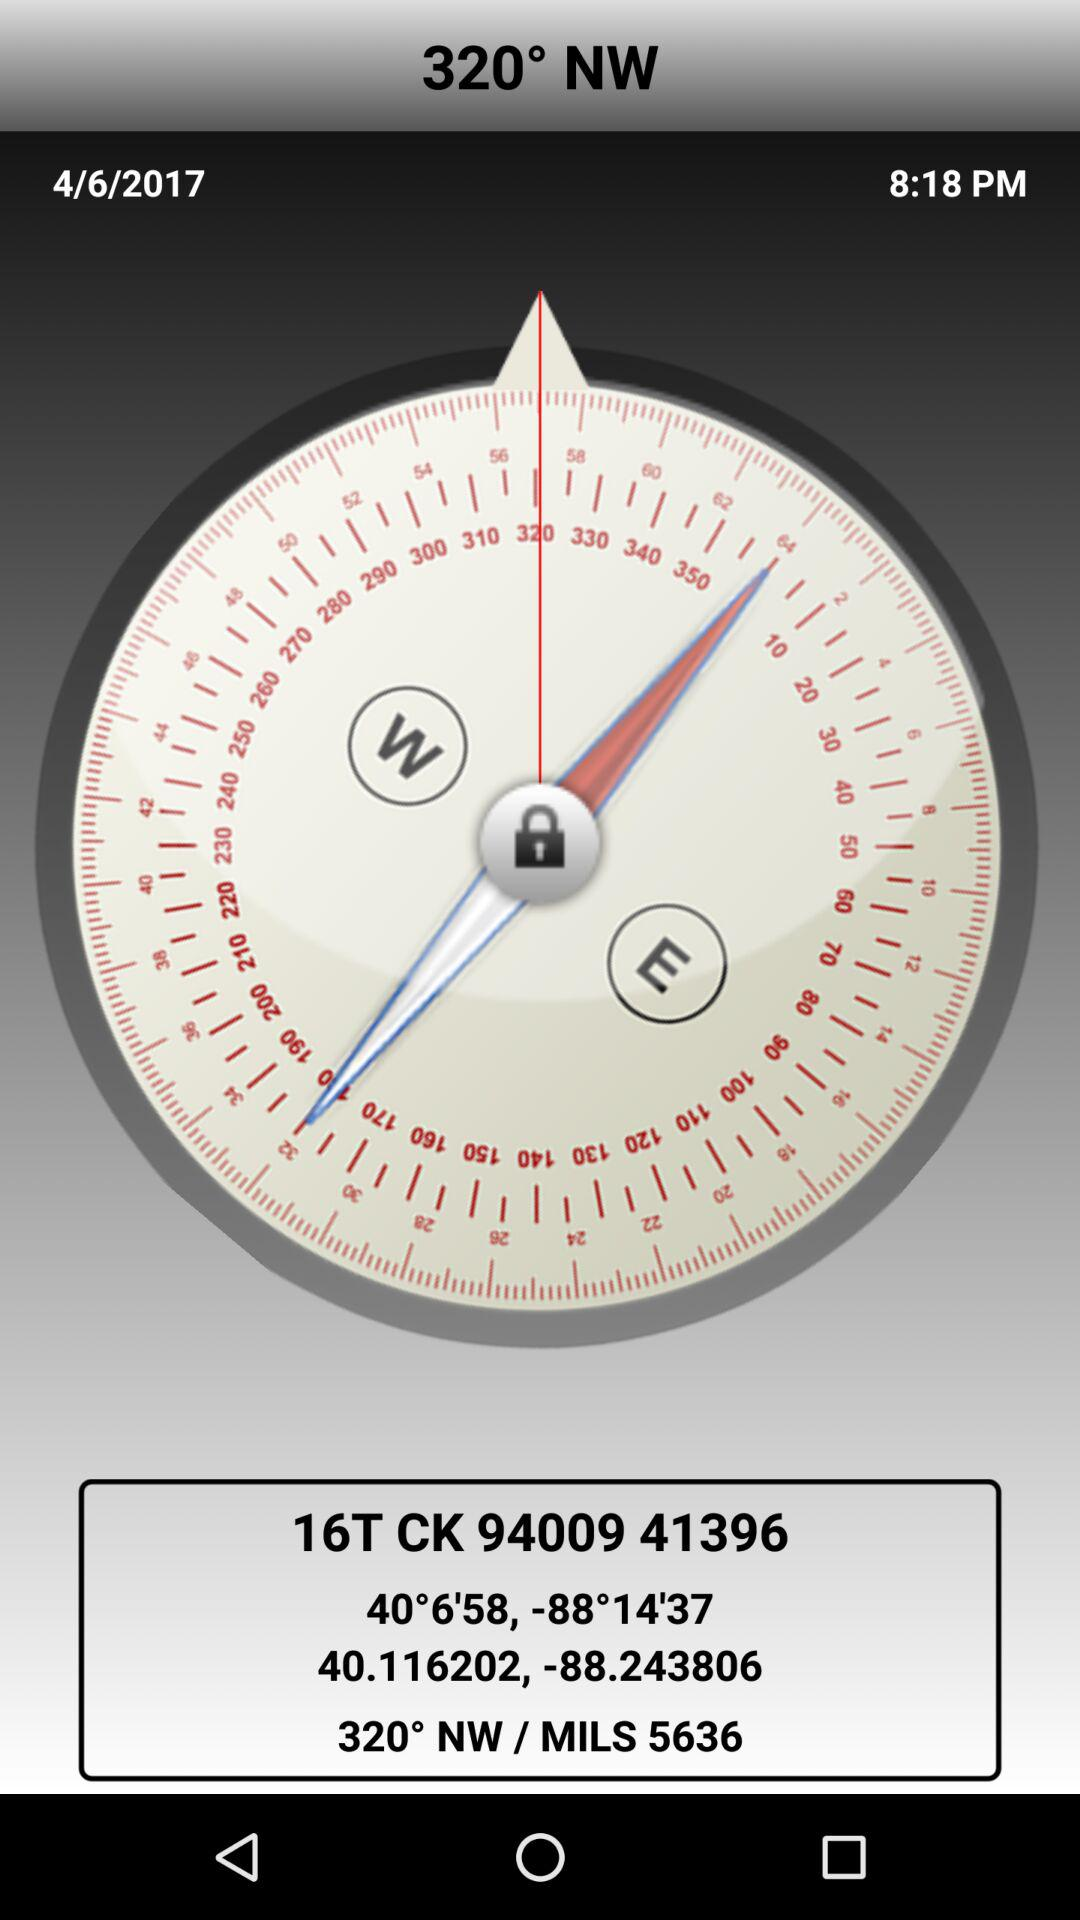In what direction is the tip of the compass pointing? The tip of the compass is pointing in the north-west direction. 